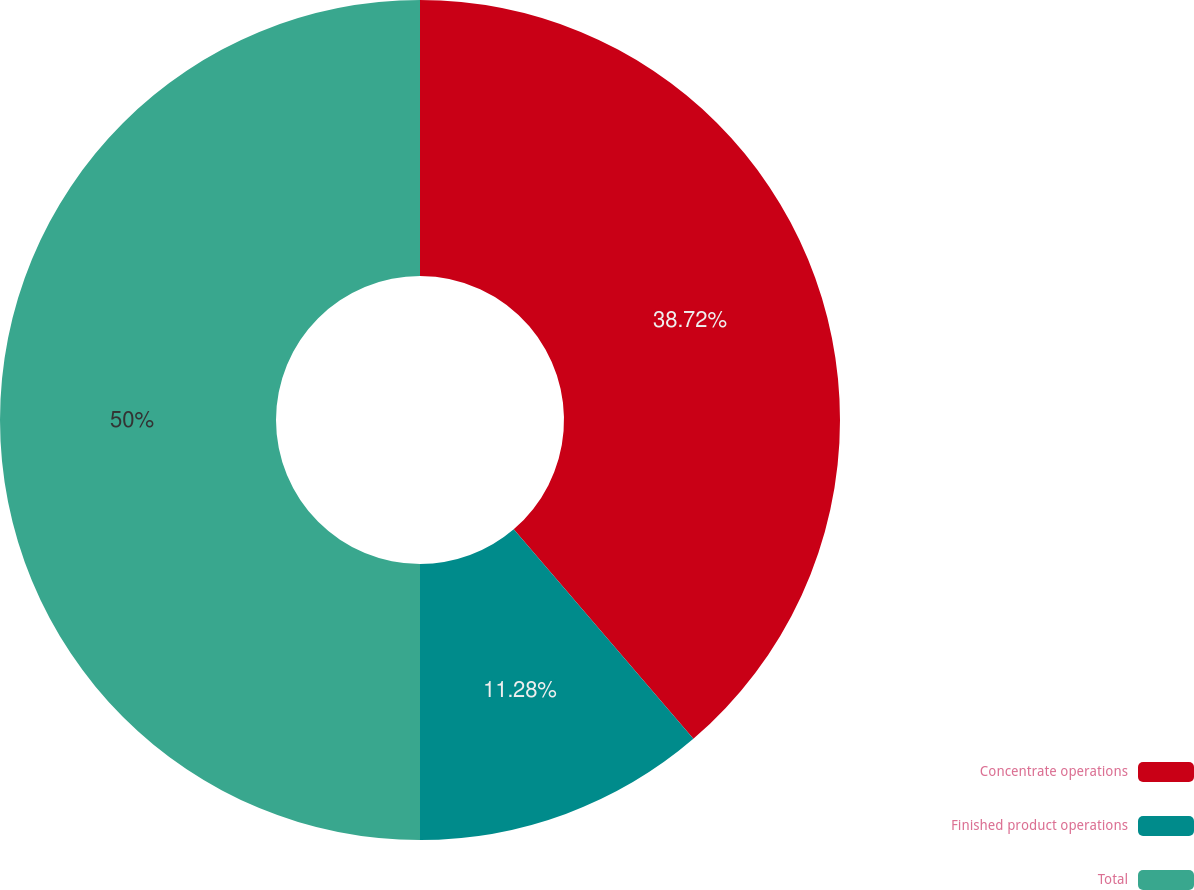<chart> <loc_0><loc_0><loc_500><loc_500><pie_chart><fcel>Concentrate operations<fcel>Finished product operations<fcel>Total<nl><fcel>38.72%<fcel>11.28%<fcel>50.0%<nl></chart> 